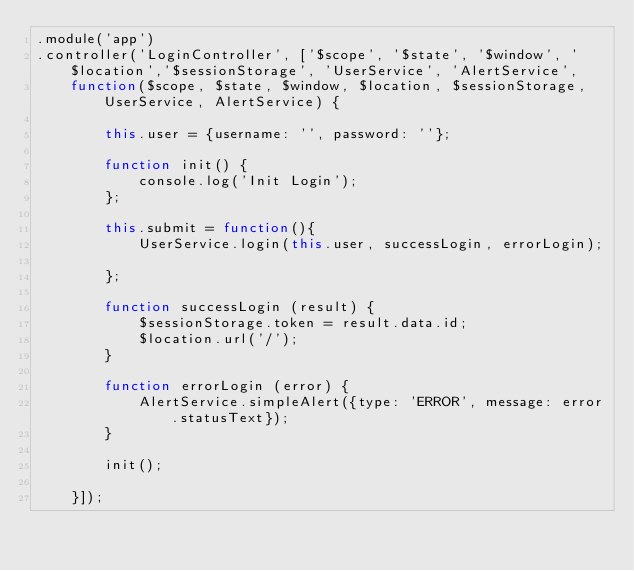<code> <loc_0><loc_0><loc_500><loc_500><_JavaScript_>.module('app')
.controller('LoginController', ['$scope', '$state', '$window', '$location','$sessionStorage', 'UserService', 'AlertService',
    function($scope, $state, $window, $location, $sessionStorage, UserService, AlertService) {

        this.user = {username: '', password: ''};

        function init() {
            console.log('Init Login');
        };

        this.submit = function(){
            UserService.login(this.user, successLogin, errorLogin);

        };

        function successLogin (result) {
            $sessionStorage.token = result.data.id;
            $location.url('/');
        }

        function errorLogin (error) {
            AlertService.simpleAlert({type: 'ERROR', message: error.statusText});
        }

        init();

    }]);
</code> 